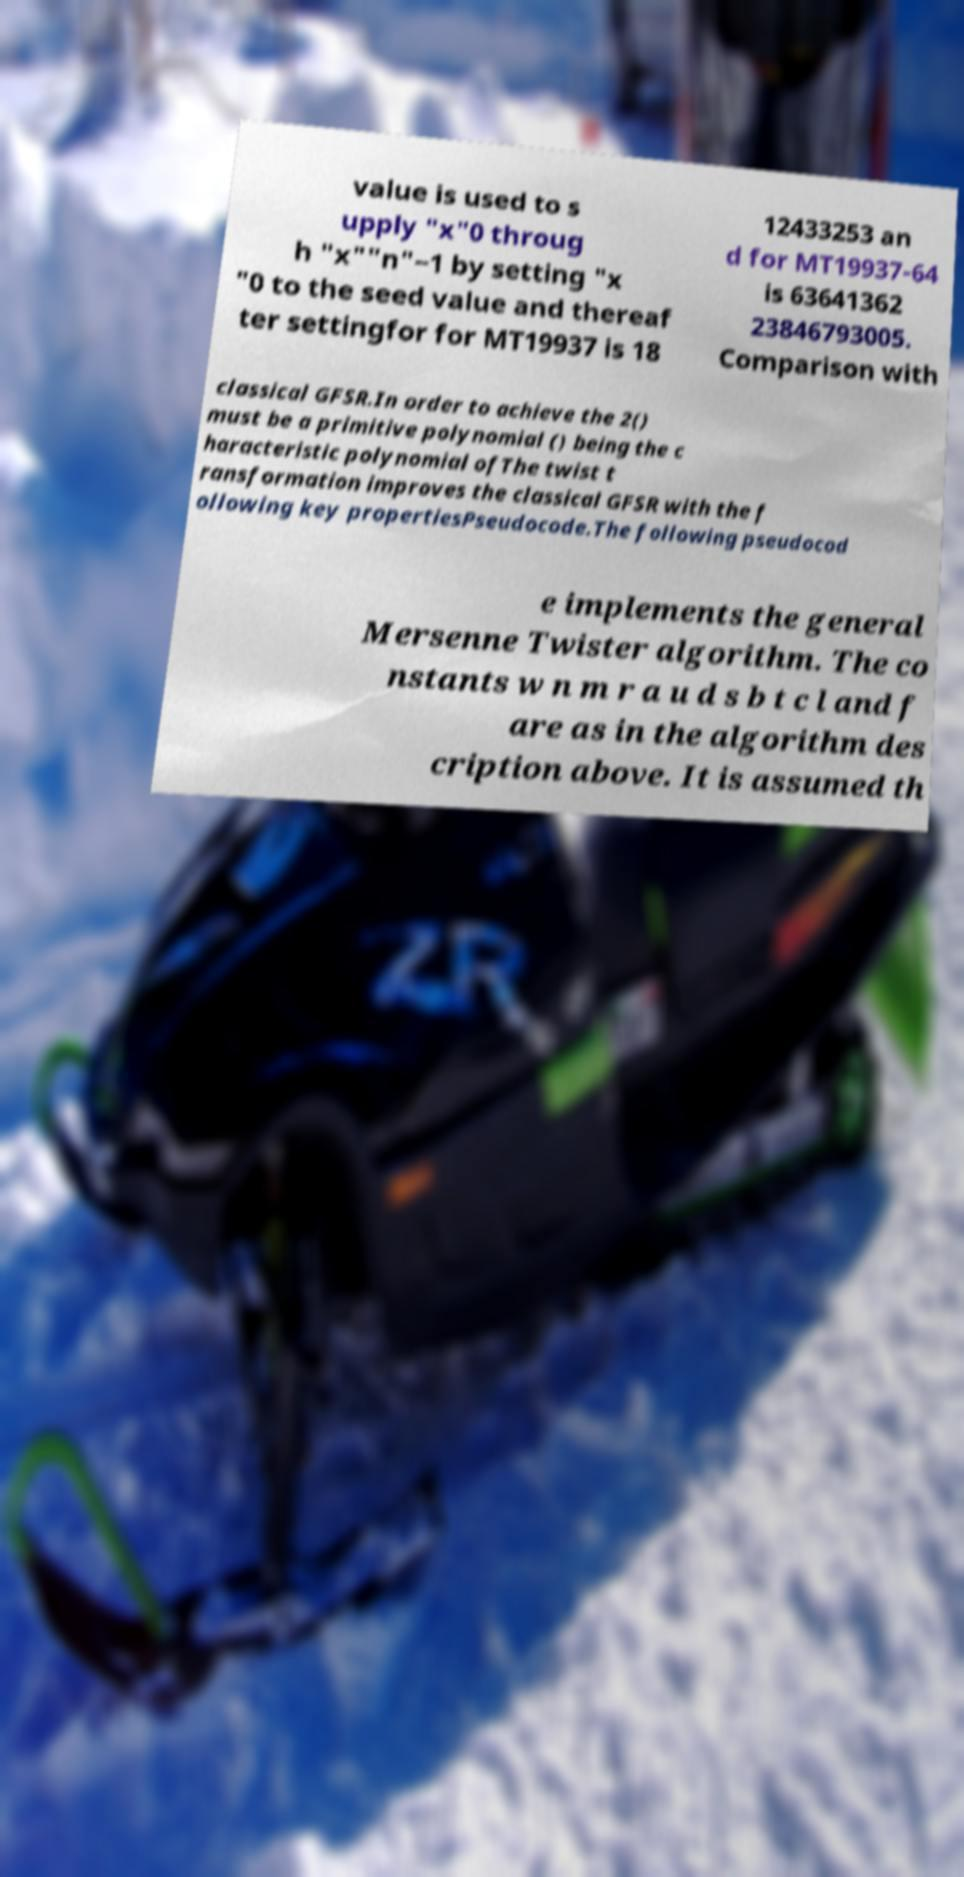Could you assist in decoding the text presented in this image and type it out clearly? value is used to s upply "x"0 throug h "x""n"−1 by setting "x "0 to the seed value and thereaf ter settingfor for MT19937 is 18 12433253 an d for MT19937-64 is 63641362 23846793005. Comparison with classical GFSR.In order to achieve the 2() must be a primitive polynomial () being the c haracteristic polynomial ofThe twist t ransformation improves the classical GFSR with the f ollowing key propertiesPseudocode.The following pseudocod e implements the general Mersenne Twister algorithm. The co nstants w n m r a u d s b t c l and f are as in the algorithm des cription above. It is assumed th 